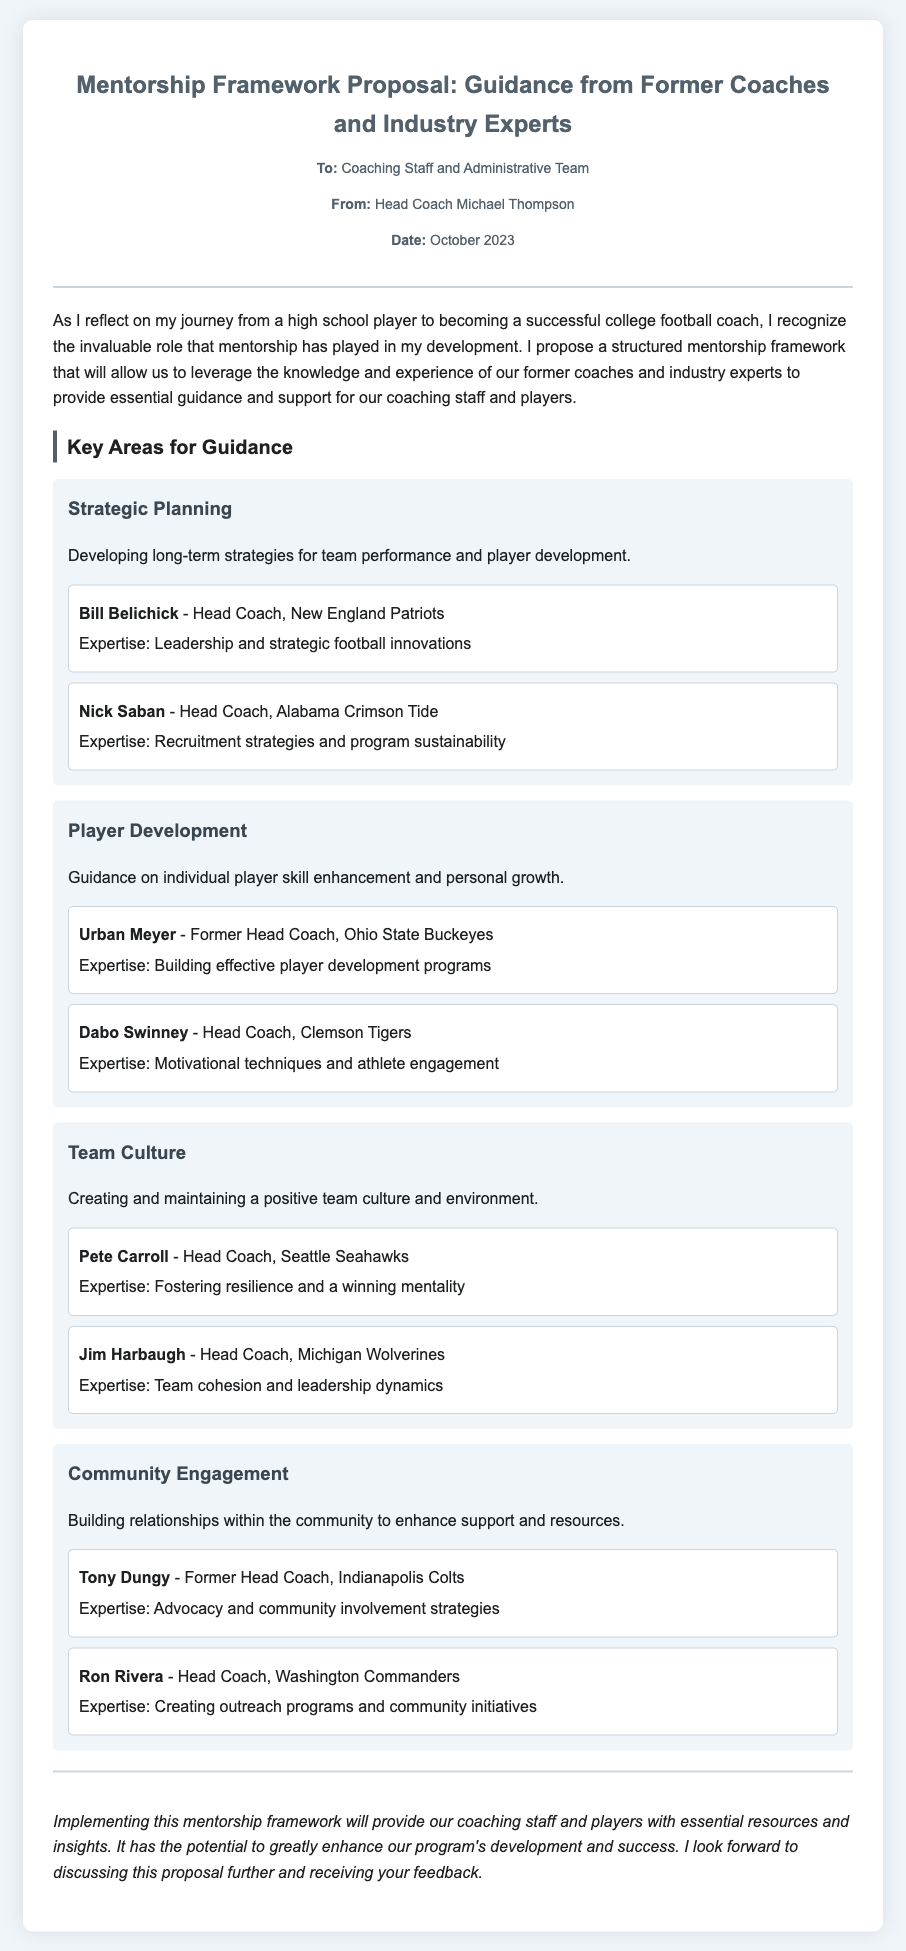What is the title of the memo? The title is clearly stated at the beginning of the document.
Answer: Mentorship Framework Proposal: Guidance from Former Coaches and Industry Experts Who is the sender of the memo? The sender is mentioned in the meta section of the document.
Answer: Head Coach Michael Thompson What is the date of the memo? The date is provided in the meta section.
Answer: October 2023 Name one mentor listed under Strategic Planning. The document lists mentors that provide guidance in each area, including Strategic Planning.
Answer: Bill Belichick Which mentor specializes in Team Culture? The document details various mentors associated with each key area; one of them focuses on Team Culture.
Answer: Pete Carroll What expertise does Urban Meyer have? The document specifies each mentor's area of expertise in player development.
Answer: Building effective player development programs How many key areas for guidance are identified in the proposal? The proposal outlines four key areas for guidance.
Answer: Four What is the focus of the Community Engagement area? The description in the document outlines the purpose of the Community Engagement area.
Answer: Building relationships within the community Who offers expertise in recruitment strategies? The document features mentors and their expertise, identifying one who specializes in recruitment strategies.
Answer: Nick Saban 